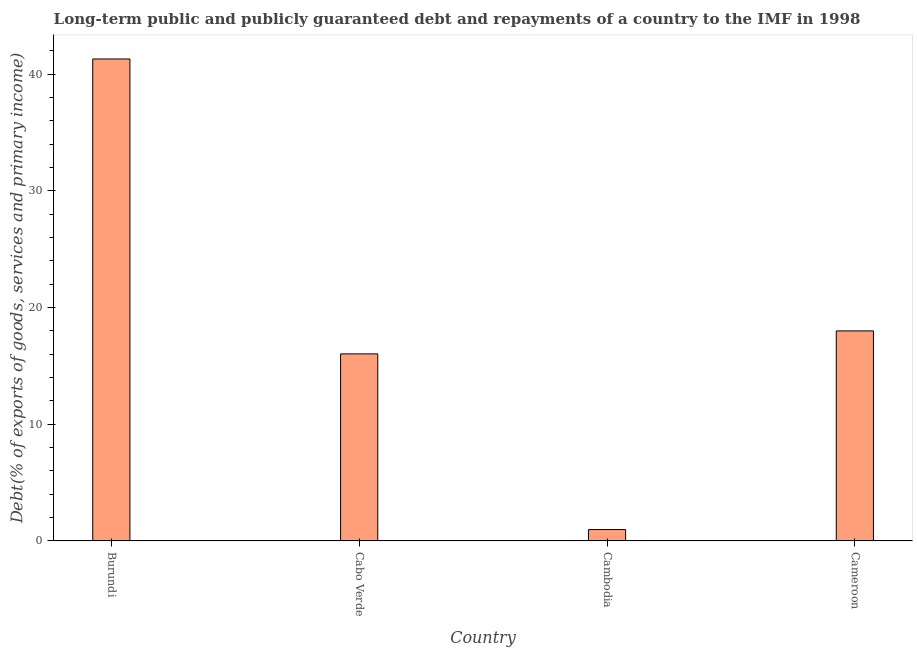What is the title of the graph?
Ensure brevity in your answer.  Long-term public and publicly guaranteed debt and repayments of a country to the IMF in 1998. What is the label or title of the X-axis?
Provide a short and direct response. Country. What is the label or title of the Y-axis?
Your answer should be very brief. Debt(% of exports of goods, services and primary income). Across all countries, what is the maximum debt service?
Provide a succinct answer. 41.3. Across all countries, what is the minimum debt service?
Provide a short and direct response. 0.97. In which country was the debt service maximum?
Your answer should be very brief. Burundi. In which country was the debt service minimum?
Keep it short and to the point. Cambodia. What is the sum of the debt service?
Provide a short and direct response. 76.31. What is the difference between the debt service in Cabo Verde and Cameroon?
Ensure brevity in your answer.  -1.97. What is the average debt service per country?
Offer a terse response. 19.08. What is the median debt service?
Offer a terse response. 17.01. In how many countries, is the debt service greater than 40 %?
Give a very brief answer. 1. What is the ratio of the debt service in Cambodia to that in Cameroon?
Provide a short and direct response. 0.05. Is the difference between the debt service in Cabo Verde and Cambodia greater than the difference between any two countries?
Provide a succinct answer. No. What is the difference between the highest and the second highest debt service?
Your response must be concise. 23.3. Is the sum of the debt service in Cabo Verde and Cameroon greater than the maximum debt service across all countries?
Provide a short and direct response. No. What is the difference between the highest and the lowest debt service?
Offer a very short reply. 40.33. In how many countries, is the debt service greater than the average debt service taken over all countries?
Offer a terse response. 1. Are all the bars in the graph horizontal?
Offer a very short reply. No. How many countries are there in the graph?
Provide a succinct answer. 4. What is the difference between two consecutive major ticks on the Y-axis?
Ensure brevity in your answer.  10. What is the Debt(% of exports of goods, services and primary income) in Burundi?
Your answer should be very brief. 41.3. What is the Debt(% of exports of goods, services and primary income) of Cabo Verde?
Make the answer very short. 16.03. What is the Debt(% of exports of goods, services and primary income) of Cambodia?
Make the answer very short. 0.97. What is the Debt(% of exports of goods, services and primary income) in Cameroon?
Give a very brief answer. 18. What is the difference between the Debt(% of exports of goods, services and primary income) in Burundi and Cabo Verde?
Your answer should be very brief. 25.27. What is the difference between the Debt(% of exports of goods, services and primary income) in Burundi and Cambodia?
Offer a terse response. 40.33. What is the difference between the Debt(% of exports of goods, services and primary income) in Burundi and Cameroon?
Keep it short and to the point. 23.3. What is the difference between the Debt(% of exports of goods, services and primary income) in Cabo Verde and Cambodia?
Provide a succinct answer. 15.06. What is the difference between the Debt(% of exports of goods, services and primary income) in Cabo Verde and Cameroon?
Make the answer very short. -1.97. What is the difference between the Debt(% of exports of goods, services and primary income) in Cambodia and Cameroon?
Your answer should be compact. -17.03. What is the ratio of the Debt(% of exports of goods, services and primary income) in Burundi to that in Cabo Verde?
Provide a short and direct response. 2.58. What is the ratio of the Debt(% of exports of goods, services and primary income) in Burundi to that in Cambodia?
Offer a terse response. 42.39. What is the ratio of the Debt(% of exports of goods, services and primary income) in Burundi to that in Cameroon?
Provide a short and direct response. 2.29. What is the ratio of the Debt(% of exports of goods, services and primary income) in Cabo Verde to that in Cambodia?
Your answer should be compact. 16.45. What is the ratio of the Debt(% of exports of goods, services and primary income) in Cabo Verde to that in Cameroon?
Offer a terse response. 0.89. What is the ratio of the Debt(% of exports of goods, services and primary income) in Cambodia to that in Cameroon?
Offer a very short reply. 0.05. 